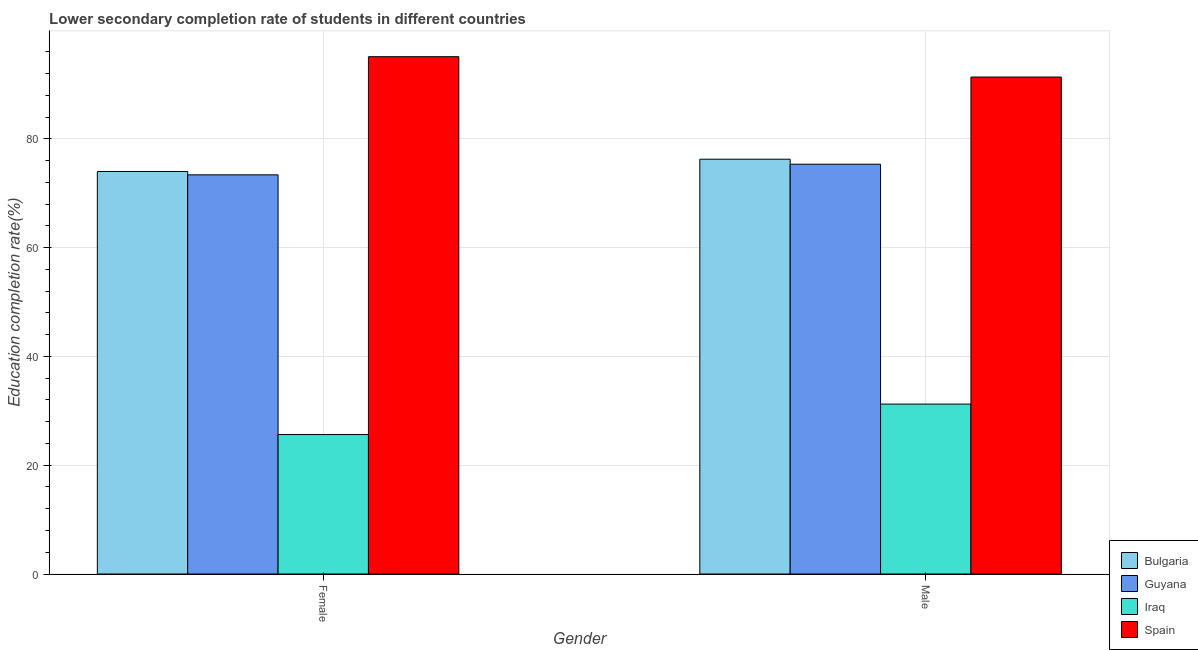How many different coloured bars are there?
Make the answer very short. 4. How many bars are there on the 1st tick from the left?
Your answer should be compact. 4. How many bars are there on the 2nd tick from the right?
Ensure brevity in your answer.  4. What is the education completion rate of female students in Iraq?
Your answer should be very brief. 25.64. Across all countries, what is the maximum education completion rate of female students?
Your answer should be very brief. 95.13. Across all countries, what is the minimum education completion rate of female students?
Make the answer very short. 25.64. In which country was the education completion rate of female students maximum?
Keep it short and to the point. Spain. In which country was the education completion rate of male students minimum?
Your response must be concise. Iraq. What is the total education completion rate of female students in the graph?
Your answer should be compact. 268.19. What is the difference between the education completion rate of female students in Iraq and that in Guyana?
Provide a succinct answer. -47.76. What is the difference between the education completion rate of male students in Guyana and the education completion rate of female students in Spain?
Offer a very short reply. -19.77. What is the average education completion rate of male students per country?
Offer a terse response. 68.57. What is the difference between the education completion rate of male students and education completion rate of female students in Iraq?
Your response must be concise. 5.6. What is the ratio of the education completion rate of female students in Guyana to that in Bulgaria?
Your answer should be very brief. 0.99. What does the 2nd bar from the left in Male represents?
Offer a terse response. Guyana. What does the 3rd bar from the right in Male represents?
Keep it short and to the point. Guyana. Are all the bars in the graph horizontal?
Make the answer very short. No. What is the difference between two consecutive major ticks on the Y-axis?
Your answer should be very brief. 20. Are the values on the major ticks of Y-axis written in scientific E-notation?
Provide a short and direct response. No. Where does the legend appear in the graph?
Your answer should be very brief. Bottom right. How are the legend labels stacked?
Offer a terse response. Vertical. What is the title of the graph?
Your answer should be very brief. Lower secondary completion rate of students in different countries. Does "Mali" appear as one of the legend labels in the graph?
Provide a short and direct response. No. What is the label or title of the X-axis?
Your answer should be very brief. Gender. What is the label or title of the Y-axis?
Ensure brevity in your answer.  Education completion rate(%). What is the Education completion rate(%) of Bulgaria in Female?
Your answer should be very brief. 74.02. What is the Education completion rate(%) of Guyana in Female?
Offer a terse response. 73.4. What is the Education completion rate(%) of Iraq in Female?
Keep it short and to the point. 25.64. What is the Education completion rate(%) of Spain in Female?
Your answer should be compact. 95.13. What is the Education completion rate(%) of Bulgaria in Male?
Provide a succinct answer. 76.27. What is the Education completion rate(%) in Guyana in Male?
Provide a short and direct response. 75.36. What is the Education completion rate(%) of Iraq in Male?
Provide a succinct answer. 31.25. What is the Education completion rate(%) in Spain in Male?
Provide a succinct answer. 91.39. Across all Gender, what is the maximum Education completion rate(%) in Bulgaria?
Provide a succinct answer. 76.27. Across all Gender, what is the maximum Education completion rate(%) in Guyana?
Offer a terse response. 75.36. Across all Gender, what is the maximum Education completion rate(%) of Iraq?
Give a very brief answer. 31.25. Across all Gender, what is the maximum Education completion rate(%) of Spain?
Ensure brevity in your answer.  95.13. Across all Gender, what is the minimum Education completion rate(%) in Bulgaria?
Ensure brevity in your answer.  74.02. Across all Gender, what is the minimum Education completion rate(%) in Guyana?
Offer a terse response. 73.4. Across all Gender, what is the minimum Education completion rate(%) of Iraq?
Offer a terse response. 25.64. Across all Gender, what is the minimum Education completion rate(%) of Spain?
Your answer should be very brief. 91.39. What is the total Education completion rate(%) in Bulgaria in the graph?
Ensure brevity in your answer.  150.29. What is the total Education completion rate(%) in Guyana in the graph?
Offer a terse response. 148.76. What is the total Education completion rate(%) of Iraq in the graph?
Your answer should be very brief. 56.89. What is the total Education completion rate(%) in Spain in the graph?
Ensure brevity in your answer.  186.51. What is the difference between the Education completion rate(%) in Bulgaria in Female and that in Male?
Provide a short and direct response. -2.26. What is the difference between the Education completion rate(%) of Guyana in Female and that in Male?
Provide a succinct answer. -1.96. What is the difference between the Education completion rate(%) of Iraq in Female and that in Male?
Offer a terse response. -5.6. What is the difference between the Education completion rate(%) of Spain in Female and that in Male?
Your answer should be compact. 3.74. What is the difference between the Education completion rate(%) in Bulgaria in Female and the Education completion rate(%) in Guyana in Male?
Your response must be concise. -1.34. What is the difference between the Education completion rate(%) in Bulgaria in Female and the Education completion rate(%) in Iraq in Male?
Provide a short and direct response. 42.77. What is the difference between the Education completion rate(%) of Bulgaria in Female and the Education completion rate(%) of Spain in Male?
Provide a short and direct response. -17.37. What is the difference between the Education completion rate(%) in Guyana in Female and the Education completion rate(%) in Iraq in Male?
Provide a succinct answer. 42.16. What is the difference between the Education completion rate(%) in Guyana in Female and the Education completion rate(%) in Spain in Male?
Make the answer very short. -17.99. What is the difference between the Education completion rate(%) of Iraq in Female and the Education completion rate(%) of Spain in Male?
Make the answer very short. -65.74. What is the average Education completion rate(%) in Bulgaria per Gender?
Make the answer very short. 75.15. What is the average Education completion rate(%) of Guyana per Gender?
Offer a very short reply. 74.38. What is the average Education completion rate(%) of Iraq per Gender?
Provide a succinct answer. 28.44. What is the average Education completion rate(%) in Spain per Gender?
Provide a succinct answer. 93.26. What is the difference between the Education completion rate(%) in Bulgaria and Education completion rate(%) in Guyana in Female?
Your answer should be compact. 0.62. What is the difference between the Education completion rate(%) of Bulgaria and Education completion rate(%) of Iraq in Female?
Keep it short and to the point. 48.38. What is the difference between the Education completion rate(%) in Bulgaria and Education completion rate(%) in Spain in Female?
Keep it short and to the point. -21.11. What is the difference between the Education completion rate(%) in Guyana and Education completion rate(%) in Iraq in Female?
Your answer should be compact. 47.76. What is the difference between the Education completion rate(%) of Guyana and Education completion rate(%) of Spain in Female?
Make the answer very short. -21.73. What is the difference between the Education completion rate(%) of Iraq and Education completion rate(%) of Spain in Female?
Offer a terse response. -69.48. What is the difference between the Education completion rate(%) in Bulgaria and Education completion rate(%) in Guyana in Male?
Offer a very short reply. 0.92. What is the difference between the Education completion rate(%) of Bulgaria and Education completion rate(%) of Iraq in Male?
Offer a very short reply. 45.03. What is the difference between the Education completion rate(%) of Bulgaria and Education completion rate(%) of Spain in Male?
Give a very brief answer. -15.11. What is the difference between the Education completion rate(%) in Guyana and Education completion rate(%) in Iraq in Male?
Your answer should be very brief. 44.11. What is the difference between the Education completion rate(%) in Guyana and Education completion rate(%) in Spain in Male?
Give a very brief answer. -16.03. What is the difference between the Education completion rate(%) of Iraq and Education completion rate(%) of Spain in Male?
Keep it short and to the point. -60.14. What is the ratio of the Education completion rate(%) of Bulgaria in Female to that in Male?
Provide a succinct answer. 0.97. What is the ratio of the Education completion rate(%) in Guyana in Female to that in Male?
Offer a very short reply. 0.97. What is the ratio of the Education completion rate(%) of Iraq in Female to that in Male?
Ensure brevity in your answer.  0.82. What is the ratio of the Education completion rate(%) in Spain in Female to that in Male?
Your response must be concise. 1.04. What is the difference between the highest and the second highest Education completion rate(%) in Bulgaria?
Keep it short and to the point. 2.26. What is the difference between the highest and the second highest Education completion rate(%) in Guyana?
Provide a succinct answer. 1.96. What is the difference between the highest and the second highest Education completion rate(%) in Iraq?
Keep it short and to the point. 5.6. What is the difference between the highest and the second highest Education completion rate(%) of Spain?
Your response must be concise. 3.74. What is the difference between the highest and the lowest Education completion rate(%) in Bulgaria?
Keep it short and to the point. 2.26. What is the difference between the highest and the lowest Education completion rate(%) of Guyana?
Offer a terse response. 1.96. What is the difference between the highest and the lowest Education completion rate(%) of Iraq?
Keep it short and to the point. 5.6. What is the difference between the highest and the lowest Education completion rate(%) in Spain?
Provide a short and direct response. 3.74. 